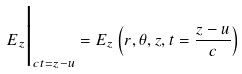<formula> <loc_0><loc_0><loc_500><loc_500>E _ { z } \Big | _ { c t = z - u } = E _ { z } \left ( r , \theta , z , t = \frac { z - u } { c } \right )</formula> 